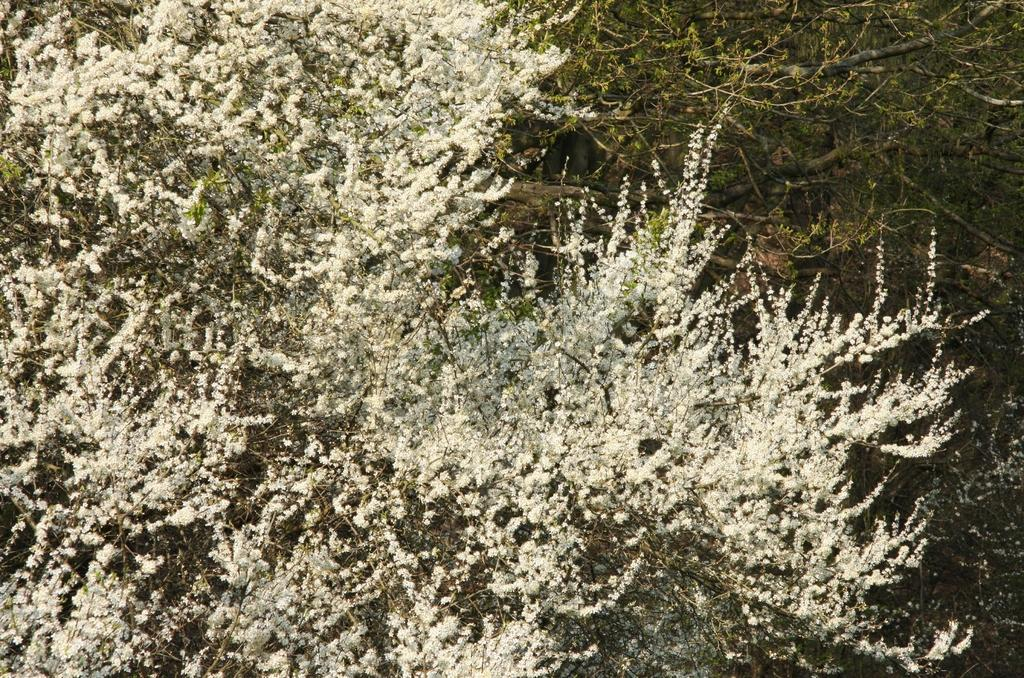What type of vegetation can be seen in the image? There are trees in the image. What type of coach is teaching in the image? There is no coach or teaching activity present in the image; it only features trees. What type of notebook is visible on the tree in the image? There is no notebook present in the image; it only features trees. 